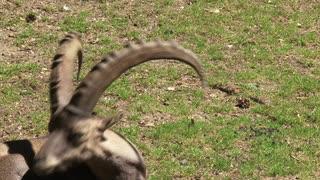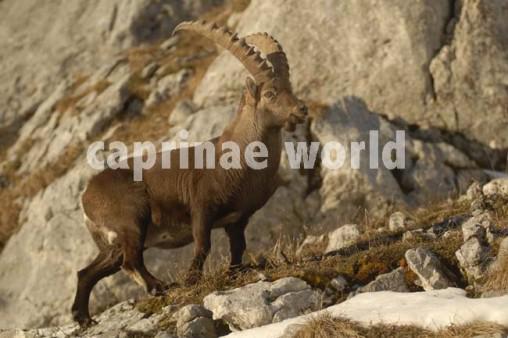The first image is the image on the left, the second image is the image on the right. Considering the images on both sides, is "There are exactly two mountain goats." valid? Answer yes or no. Yes. The first image is the image on the left, the second image is the image on the right. Evaluate the accuracy of this statement regarding the images: "There are only two goats visible.". Is it true? Answer yes or no. Yes. 